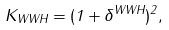Convert formula to latex. <formula><loc_0><loc_0><loc_500><loc_500>K _ { W W H } = ( 1 + \delta ^ { W W H } ) ^ { 2 } ,</formula> 